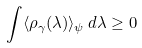Convert formula to latex. <formula><loc_0><loc_0><loc_500><loc_500>\int \langle \rho _ { \gamma } ( \lambda ) \rangle _ { \psi } \, d \lambda \geq 0</formula> 